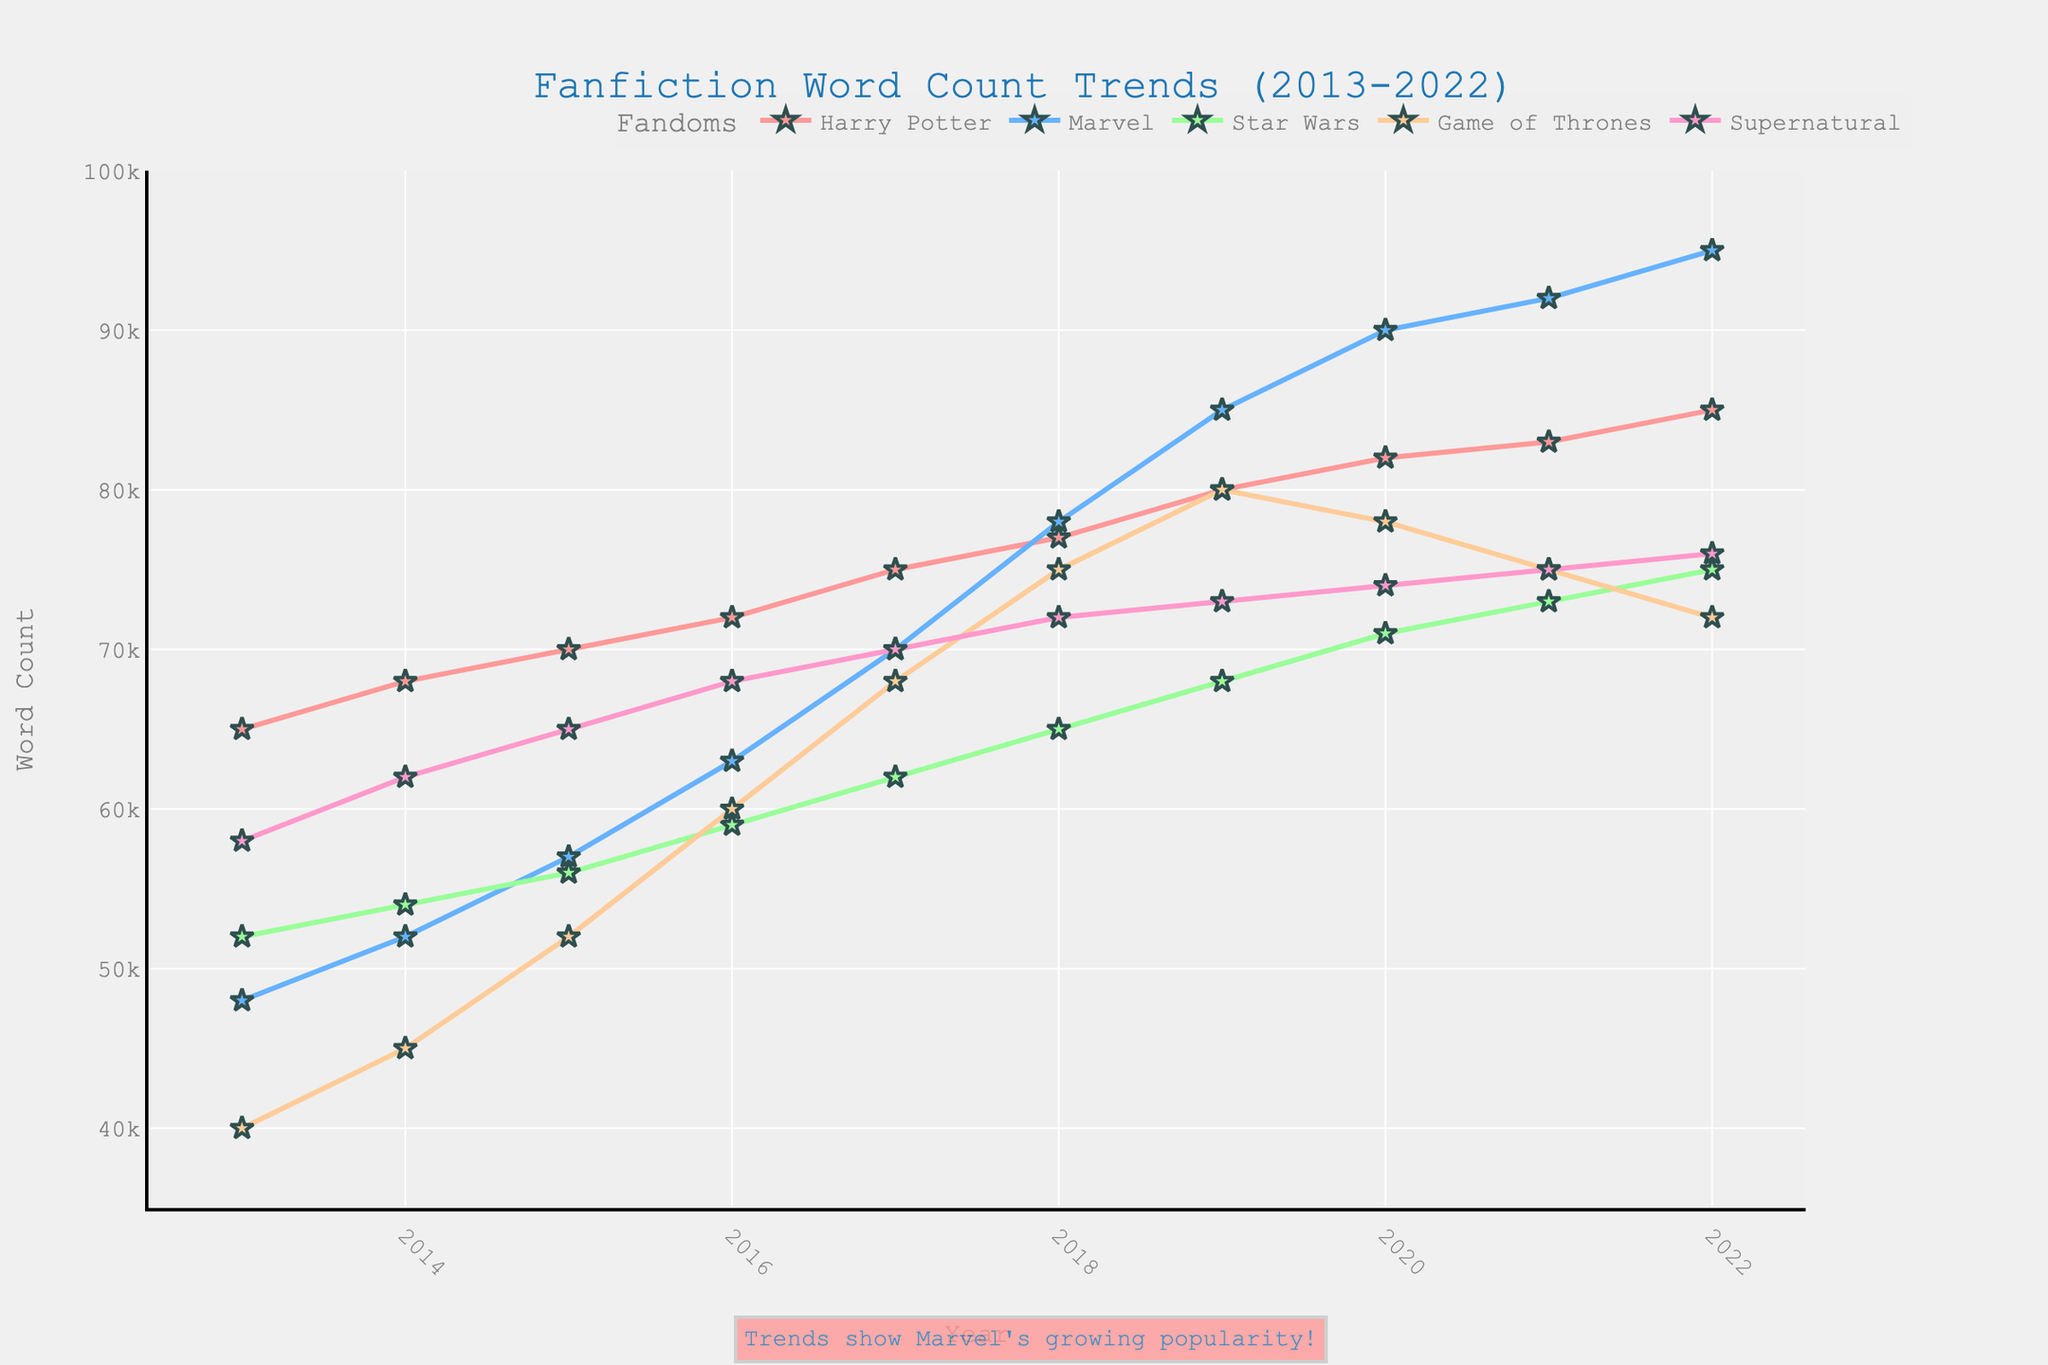Which fandom had the highest word count in 2022? Look at the data points for 2022 and identify the highest point. Marvel has the highest word count in 2022.
Answer: Marvel How does the trend in word count for "Harry Potter" compare to "Game of Thrones" from 2013 to 2022? Observe the trajectories of both trends. Harry Potter's word count consistently increases, while Game of Thrones shows a peak around 2019 and a decline thereafter.
Answer: Harry Potter increases, Game of Thrones peaks and declines Which fandom experienced the largest increase in word count from 2013 to 2022? Calculate the difference between the word count in 2022 and 2013 for each fandom. Marvel's increase (95000 - 48000 = 47000) is the largest.
Answer: Marvel What is the difference in word count between Marvel and Supernatural in 2020? Subtract Supernatural's word count from Marvel's word count in 2020 (90000 - 74000 = 16000).
Answer: 16000 Which two fandoms had the closest word counts in 2021? Compare the word counts in 2021 and identify the pair with the smallest difference. Star Wars (73000) and Game of Thrones (75000) are closest.
Answer: Star Wars and Game of Thrones What is the overall trend in word count for "Supernatural" from 2013 to 2022? Track the word count of Supernatural across the years. It shows a steady increase from 58000 to 76000.
Answer: Steady increase Which year showed the most significant spike in word count for the "Marvel" fandom? Identify the year-to-year increases for Marvel and find the largest jump. The biggest spike is from 2018 to 2019 (85000 - 78000 = 7000).
Answer: 2019 What is the combined word count for "Harry Potter" and "Star Wars" in 2017? Add the word counts of Harry Potter and Star Wars in 2017 (75000 + 62000 = 137000).
Answer: 137000 What was the average word count for “Game of Thrones” over the decade? Sum the word counts of Game of Thrones from 2013 to 2022 and divide by 10 ((40000 + 45000 + 52000 + 60000 + 68000 + 75000 + 80000 + 78000 + 75000 + 72000)/10 = 64500).
Answer: 64500 Which fandom showed a decline in word count after 2019? Identify any fandom whose word count decreases after 2019. Both Game of Thrones (from 80000 to 72000) and Star Wars (from 71000 to 72000) show a decline.
Answer: Game of Thrones and Star Wars 